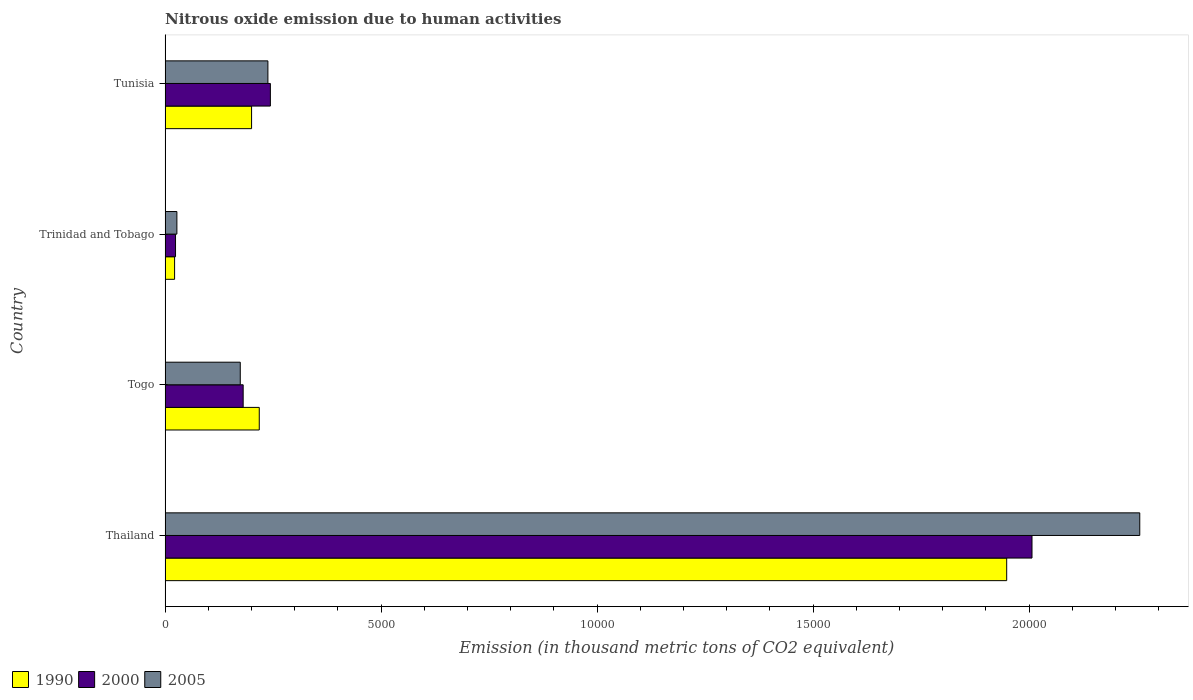How many groups of bars are there?
Your answer should be compact. 4. How many bars are there on the 3rd tick from the top?
Ensure brevity in your answer.  3. What is the label of the 4th group of bars from the top?
Make the answer very short. Thailand. In how many cases, is the number of bars for a given country not equal to the number of legend labels?
Your answer should be compact. 0. What is the amount of nitrous oxide emitted in 1990 in Tunisia?
Give a very brief answer. 2001.7. Across all countries, what is the maximum amount of nitrous oxide emitted in 2000?
Offer a very short reply. 2.01e+04. Across all countries, what is the minimum amount of nitrous oxide emitted in 1990?
Your answer should be very brief. 219.9. In which country was the amount of nitrous oxide emitted in 1990 maximum?
Your response must be concise. Thailand. In which country was the amount of nitrous oxide emitted in 2005 minimum?
Ensure brevity in your answer.  Trinidad and Tobago. What is the total amount of nitrous oxide emitted in 2005 in the graph?
Make the answer very short. 2.70e+04. What is the difference between the amount of nitrous oxide emitted in 2000 in Thailand and that in Tunisia?
Offer a terse response. 1.76e+04. What is the difference between the amount of nitrous oxide emitted in 1990 in Thailand and the amount of nitrous oxide emitted in 2000 in Togo?
Provide a succinct answer. 1.77e+04. What is the average amount of nitrous oxide emitted in 2000 per country?
Offer a terse response. 6137.68. What is the difference between the amount of nitrous oxide emitted in 2005 and amount of nitrous oxide emitted in 2000 in Tunisia?
Your answer should be compact. -57.2. What is the ratio of the amount of nitrous oxide emitted in 1990 in Trinidad and Tobago to that in Tunisia?
Offer a terse response. 0.11. What is the difference between the highest and the second highest amount of nitrous oxide emitted in 2005?
Ensure brevity in your answer.  2.02e+04. What is the difference between the highest and the lowest amount of nitrous oxide emitted in 1990?
Ensure brevity in your answer.  1.93e+04. What does the 1st bar from the top in Togo represents?
Give a very brief answer. 2005. Is it the case that in every country, the sum of the amount of nitrous oxide emitted in 1990 and amount of nitrous oxide emitted in 2005 is greater than the amount of nitrous oxide emitted in 2000?
Provide a short and direct response. Yes. How many bars are there?
Provide a short and direct response. 12. Are all the bars in the graph horizontal?
Your answer should be compact. Yes. What is the difference between two consecutive major ticks on the X-axis?
Your answer should be compact. 5000. Are the values on the major ticks of X-axis written in scientific E-notation?
Provide a short and direct response. No. Does the graph contain grids?
Make the answer very short. No. What is the title of the graph?
Offer a very short reply. Nitrous oxide emission due to human activities. What is the label or title of the X-axis?
Provide a succinct answer. Emission (in thousand metric tons of CO2 equivalent). What is the Emission (in thousand metric tons of CO2 equivalent) of 1990 in Thailand?
Ensure brevity in your answer.  1.95e+04. What is the Emission (in thousand metric tons of CO2 equivalent) in 2000 in Thailand?
Your answer should be very brief. 2.01e+04. What is the Emission (in thousand metric tons of CO2 equivalent) in 2005 in Thailand?
Provide a succinct answer. 2.26e+04. What is the Emission (in thousand metric tons of CO2 equivalent) of 1990 in Togo?
Make the answer very short. 2179.7. What is the Emission (in thousand metric tons of CO2 equivalent) of 2000 in Togo?
Your answer should be compact. 1807. What is the Emission (in thousand metric tons of CO2 equivalent) of 2005 in Togo?
Make the answer very short. 1739.7. What is the Emission (in thousand metric tons of CO2 equivalent) of 1990 in Trinidad and Tobago?
Offer a terse response. 219.9. What is the Emission (in thousand metric tons of CO2 equivalent) in 2000 in Trinidad and Tobago?
Your answer should be very brief. 241.5. What is the Emission (in thousand metric tons of CO2 equivalent) in 2005 in Trinidad and Tobago?
Provide a succinct answer. 272.8. What is the Emission (in thousand metric tons of CO2 equivalent) in 1990 in Tunisia?
Provide a short and direct response. 2001.7. What is the Emission (in thousand metric tons of CO2 equivalent) in 2000 in Tunisia?
Make the answer very short. 2436.9. What is the Emission (in thousand metric tons of CO2 equivalent) of 2005 in Tunisia?
Keep it short and to the point. 2379.7. Across all countries, what is the maximum Emission (in thousand metric tons of CO2 equivalent) of 1990?
Your answer should be compact. 1.95e+04. Across all countries, what is the maximum Emission (in thousand metric tons of CO2 equivalent) of 2000?
Your response must be concise. 2.01e+04. Across all countries, what is the maximum Emission (in thousand metric tons of CO2 equivalent) in 2005?
Provide a short and direct response. 2.26e+04. Across all countries, what is the minimum Emission (in thousand metric tons of CO2 equivalent) in 1990?
Offer a very short reply. 219.9. Across all countries, what is the minimum Emission (in thousand metric tons of CO2 equivalent) in 2000?
Your response must be concise. 241.5. Across all countries, what is the minimum Emission (in thousand metric tons of CO2 equivalent) in 2005?
Make the answer very short. 272.8. What is the total Emission (in thousand metric tons of CO2 equivalent) of 1990 in the graph?
Your answer should be compact. 2.39e+04. What is the total Emission (in thousand metric tons of CO2 equivalent) in 2000 in the graph?
Offer a very short reply. 2.46e+04. What is the total Emission (in thousand metric tons of CO2 equivalent) in 2005 in the graph?
Provide a succinct answer. 2.70e+04. What is the difference between the Emission (in thousand metric tons of CO2 equivalent) of 1990 in Thailand and that in Togo?
Your answer should be very brief. 1.73e+04. What is the difference between the Emission (in thousand metric tons of CO2 equivalent) in 2000 in Thailand and that in Togo?
Your response must be concise. 1.83e+04. What is the difference between the Emission (in thousand metric tons of CO2 equivalent) in 2005 in Thailand and that in Togo?
Give a very brief answer. 2.08e+04. What is the difference between the Emission (in thousand metric tons of CO2 equivalent) in 1990 in Thailand and that in Trinidad and Tobago?
Ensure brevity in your answer.  1.93e+04. What is the difference between the Emission (in thousand metric tons of CO2 equivalent) of 2000 in Thailand and that in Trinidad and Tobago?
Provide a short and direct response. 1.98e+04. What is the difference between the Emission (in thousand metric tons of CO2 equivalent) in 2005 in Thailand and that in Trinidad and Tobago?
Provide a succinct answer. 2.23e+04. What is the difference between the Emission (in thousand metric tons of CO2 equivalent) of 1990 in Thailand and that in Tunisia?
Offer a very short reply. 1.75e+04. What is the difference between the Emission (in thousand metric tons of CO2 equivalent) of 2000 in Thailand and that in Tunisia?
Give a very brief answer. 1.76e+04. What is the difference between the Emission (in thousand metric tons of CO2 equivalent) of 2005 in Thailand and that in Tunisia?
Give a very brief answer. 2.02e+04. What is the difference between the Emission (in thousand metric tons of CO2 equivalent) of 1990 in Togo and that in Trinidad and Tobago?
Keep it short and to the point. 1959.8. What is the difference between the Emission (in thousand metric tons of CO2 equivalent) in 2000 in Togo and that in Trinidad and Tobago?
Provide a succinct answer. 1565.5. What is the difference between the Emission (in thousand metric tons of CO2 equivalent) of 2005 in Togo and that in Trinidad and Tobago?
Provide a succinct answer. 1466.9. What is the difference between the Emission (in thousand metric tons of CO2 equivalent) of 1990 in Togo and that in Tunisia?
Keep it short and to the point. 178. What is the difference between the Emission (in thousand metric tons of CO2 equivalent) of 2000 in Togo and that in Tunisia?
Your answer should be compact. -629.9. What is the difference between the Emission (in thousand metric tons of CO2 equivalent) of 2005 in Togo and that in Tunisia?
Keep it short and to the point. -640. What is the difference between the Emission (in thousand metric tons of CO2 equivalent) of 1990 in Trinidad and Tobago and that in Tunisia?
Provide a short and direct response. -1781.8. What is the difference between the Emission (in thousand metric tons of CO2 equivalent) of 2000 in Trinidad and Tobago and that in Tunisia?
Offer a terse response. -2195.4. What is the difference between the Emission (in thousand metric tons of CO2 equivalent) in 2005 in Trinidad and Tobago and that in Tunisia?
Your answer should be compact. -2106.9. What is the difference between the Emission (in thousand metric tons of CO2 equivalent) of 1990 in Thailand and the Emission (in thousand metric tons of CO2 equivalent) of 2000 in Togo?
Your response must be concise. 1.77e+04. What is the difference between the Emission (in thousand metric tons of CO2 equivalent) in 1990 in Thailand and the Emission (in thousand metric tons of CO2 equivalent) in 2005 in Togo?
Give a very brief answer. 1.77e+04. What is the difference between the Emission (in thousand metric tons of CO2 equivalent) of 2000 in Thailand and the Emission (in thousand metric tons of CO2 equivalent) of 2005 in Togo?
Your response must be concise. 1.83e+04. What is the difference between the Emission (in thousand metric tons of CO2 equivalent) of 1990 in Thailand and the Emission (in thousand metric tons of CO2 equivalent) of 2000 in Trinidad and Tobago?
Offer a terse response. 1.92e+04. What is the difference between the Emission (in thousand metric tons of CO2 equivalent) of 1990 in Thailand and the Emission (in thousand metric tons of CO2 equivalent) of 2005 in Trinidad and Tobago?
Provide a short and direct response. 1.92e+04. What is the difference between the Emission (in thousand metric tons of CO2 equivalent) of 2000 in Thailand and the Emission (in thousand metric tons of CO2 equivalent) of 2005 in Trinidad and Tobago?
Make the answer very short. 1.98e+04. What is the difference between the Emission (in thousand metric tons of CO2 equivalent) in 1990 in Thailand and the Emission (in thousand metric tons of CO2 equivalent) in 2000 in Tunisia?
Your answer should be compact. 1.70e+04. What is the difference between the Emission (in thousand metric tons of CO2 equivalent) of 1990 in Thailand and the Emission (in thousand metric tons of CO2 equivalent) of 2005 in Tunisia?
Keep it short and to the point. 1.71e+04. What is the difference between the Emission (in thousand metric tons of CO2 equivalent) in 2000 in Thailand and the Emission (in thousand metric tons of CO2 equivalent) in 2005 in Tunisia?
Offer a terse response. 1.77e+04. What is the difference between the Emission (in thousand metric tons of CO2 equivalent) of 1990 in Togo and the Emission (in thousand metric tons of CO2 equivalent) of 2000 in Trinidad and Tobago?
Offer a very short reply. 1938.2. What is the difference between the Emission (in thousand metric tons of CO2 equivalent) in 1990 in Togo and the Emission (in thousand metric tons of CO2 equivalent) in 2005 in Trinidad and Tobago?
Keep it short and to the point. 1906.9. What is the difference between the Emission (in thousand metric tons of CO2 equivalent) in 2000 in Togo and the Emission (in thousand metric tons of CO2 equivalent) in 2005 in Trinidad and Tobago?
Provide a succinct answer. 1534.2. What is the difference between the Emission (in thousand metric tons of CO2 equivalent) of 1990 in Togo and the Emission (in thousand metric tons of CO2 equivalent) of 2000 in Tunisia?
Provide a succinct answer. -257.2. What is the difference between the Emission (in thousand metric tons of CO2 equivalent) in 1990 in Togo and the Emission (in thousand metric tons of CO2 equivalent) in 2005 in Tunisia?
Your response must be concise. -200. What is the difference between the Emission (in thousand metric tons of CO2 equivalent) of 2000 in Togo and the Emission (in thousand metric tons of CO2 equivalent) of 2005 in Tunisia?
Ensure brevity in your answer.  -572.7. What is the difference between the Emission (in thousand metric tons of CO2 equivalent) in 1990 in Trinidad and Tobago and the Emission (in thousand metric tons of CO2 equivalent) in 2000 in Tunisia?
Offer a terse response. -2217. What is the difference between the Emission (in thousand metric tons of CO2 equivalent) in 1990 in Trinidad and Tobago and the Emission (in thousand metric tons of CO2 equivalent) in 2005 in Tunisia?
Your response must be concise. -2159.8. What is the difference between the Emission (in thousand metric tons of CO2 equivalent) in 2000 in Trinidad and Tobago and the Emission (in thousand metric tons of CO2 equivalent) in 2005 in Tunisia?
Your answer should be very brief. -2138.2. What is the average Emission (in thousand metric tons of CO2 equivalent) in 1990 per country?
Offer a terse response. 5970.1. What is the average Emission (in thousand metric tons of CO2 equivalent) in 2000 per country?
Offer a terse response. 6137.68. What is the average Emission (in thousand metric tons of CO2 equivalent) in 2005 per country?
Offer a terse response. 6737.88. What is the difference between the Emission (in thousand metric tons of CO2 equivalent) of 1990 and Emission (in thousand metric tons of CO2 equivalent) of 2000 in Thailand?
Give a very brief answer. -586.2. What is the difference between the Emission (in thousand metric tons of CO2 equivalent) in 1990 and Emission (in thousand metric tons of CO2 equivalent) in 2005 in Thailand?
Offer a terse response. -3080.2. What is the difference between the Emission (in thousand metric tons of CO2 equivalent) in 2000 and Emission (in thousand metric tons of CO2 equivalent) in 2005 in Thailand?
Your answer should be compact. -2494. What is the difference between the Emission (in thousand metric tons of CO2 equivalent) of 1990 and Emission (in thousand metric tons of CO2 equivalent) of 2000 in Togo?
Provide a succinct answer. 372.7. What is the difference between the Emission (in thousand metric tons of CO2 equivalent) in 1990 and Emission (in thousand metric tons of CO2 equivalent) in 2005 in Togo?
Your answer should be compact. 440. What is the difference between the Emission (in thousand metric tons of CO2 equivalent) in 2000 and Emission (in thousand metric tons of CO2 equivalent) in 2005 in Togo?
Provide a short and direct response. 67.3. What is the difference between the Emission (in thousand metric tons of CO2 equivalent) of 1990 and Emission (in thousand metric tons of CO2 equivalent) of 2000 in Trinidad and Tobago?
Ensure brevity in your answer.  -21.6. What is the difference between the Emission (in thousand metric tons of CO2 equivalent) in 1990 and Emission (in thousand metric tons of CO2 equivalent) in 2005 in Trinidad and Tobago?
Provide a succinct answer. -52.9. What is the difference between the Emission (in thousand metric tons of CO2 equivalent) of 2000 and Emission (in thousand metric tons of CO2 equivalent) of 2005 in Trinidad and Tobago?
Ensure brevity in your answer.  -31.3. What is the difference between the Emission (in thousand metric tons of CO2 equivalent) of 1990 and Emission (in thousand metric tons of CO2 equivalent) of 2000 in Tunisia?
Your answer should be compact. -435.2. What is the difference between the Emission (in thousand metric tons of CO2 equivalent) of 1990 and Emission (in thousand metric tons of CO2 equivalent) of 2005 in Tunisia?
Offer a very short reply. -378. What is the difference between the Emission (in thousand metric tons of CO2 equivalent) of 2000 and Emission (in thousand metric tons of CO2 equivalent) of 2005 in Tunisia?
Your answer should be very brief. 57.2. What is the ratio of the Emission (in thousand metric tons of CO2 equivalent) of 1990 in Thailand to that in Togo?
Offer a terse response. 8.94. What is the ratio of the Emission (in thousand metric tons of CO2 equivalent) of 2000 in Thailand to that in Togo?
Your answer should be very brief. 11.1. What is the ratio of the Emission (in thousand metric tons of CO2 equivalent) in 2005 in Thailand to that in Togo?
Provide a succinct answer. 12.97. What is the ratio of the Emission (in thousand metric tons of CO2 equivalent) of 1990 in Thailand to that in Trinidad and Tobago?
Make the answer very short. 88.58. What is the ratio of the Emission (in thousand metric tons of CO2 equivalent) of 2000 in Thailand to that in Trinidad and Tobago?
Provide a succinct answer. 83.09. What is the ratio of the Emission (in thousand metric tons of CO2 equivalent) of 2005 in Thailand to that in Trinidad and Tobago?
Your response must be concise. 82.7. What is the ratio of the Emission (in thousand metric tons of CO2 equivalent) in 1990 in Thailand to that in Tunisia?
Give a very brief answer. 9.73. What is the ratio of the Emission (in thousand metric tons of CO2 equivalent) in 2000 in Thailand to that in Tunisia?
Offer a terse response. 8.23. What is the ratio of the Emission (in thousand metric tons of CO2 equivalent) of 2005 in Thailand to that in Tunisia?
Offer a very short reply. 9.48. What is the ratio of the Emission (in thousand metric tons of CO2 equivalent) of 1990 in Togo to that in Trinidad and Tobago?
Your answer should be very brief. 9.91. What is the ratio of the Emission (in thousand metric tons of CO2 equivalent) in 2000 in Togo to that in Trinidad and Tobago?
Provide a succinct answer. 7.48. What is the ratio of the Emission (in thousand metric tons of CO2 equivalent) in 2005 in Togo to that in Trinidad and Tobago?
Offer a terse response. 6.38. What is the ratio of the Emission (in thousand metric tons of CO2 equivalent) of 1990 in Togo to that in Tunisia?
Your answer should be very brief. 1.09. What is the ratio of the Emission (in thousand metric tons of CO2 equivalent) in 2000 in Togo to that in Tunisia?
Offer a terse response. 0.74. What is the ratio of the Emission (in thousand metric tons of CO2 equivalent) of 2005 in Togo to that in Tunisia?
Your answer should be compact. 0.73. What is the ratio of the Emission (in thousand metric tons of CO2 equivalent) of 1990 in Trinidad and Tobago to that in Tunisia?
Provide a short and direct response. 0.11. What is the ratio of the Emission (in thousand metric tons of CO2 equivalent) in 2000 in Trinidad and Tobago to that in Tunisia?
Give a very brief answer. 0.1. What is the ratio of the Emission (in thousand metric tons of CO2 equivalent) of 2005 in Trinidad and Tobago to that in Tunisia?
Your response must be concise. 0.11. What is the difference between the highest and the second highest Emission (in thousand metric tons of CO2 equivalent) in 1990?
Keep it short and to the point. 1.73e+04. What is the difference between the highest and the second highest Emission (in thousand metric tons of CO2 equivalent) in 2000?
Your answer should be compact. 1.76e+04. What is the difference between the highest and the second highest Emission (in thousand metric tons of CO2 equivalent) of 2005?
Keep it short and to the point. 2.02e+04. What is the difference between the highest and the lowest Emission (in thousand metric tons of CO2 equivalent) of 1990?
Offer a very short reply. 1.93e+04. What is the difference between the highest and the lowest Emission (in thousand metric tons of CO2 equivalent) of 2000?
Your answer should be very brief. 1.98e+04. What is the difference between the highest and the lowest Emission (in thousand metric tons of CO2 equivalent) of 2005?
Keep it short and to the point. 2.23e+04. 